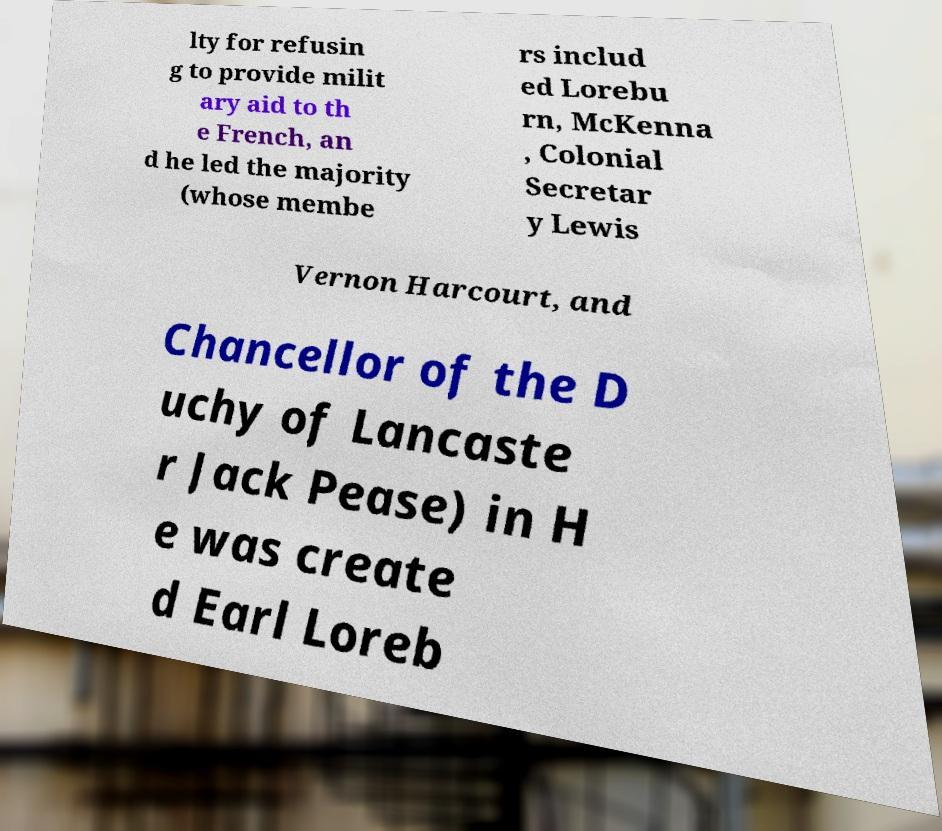Please identify and transcribe the text found in this image. lty for refusin g to provide milit ary aid to th e French, an d he led the majority (whose membe rs includ ed Lorebu rn, McKenna , Colonial Secretar y Lewis Vernon Harcourt, and Chancellor of the D uchy of Lancaste r Jack Pease) in H e was create d Earl Loreb 